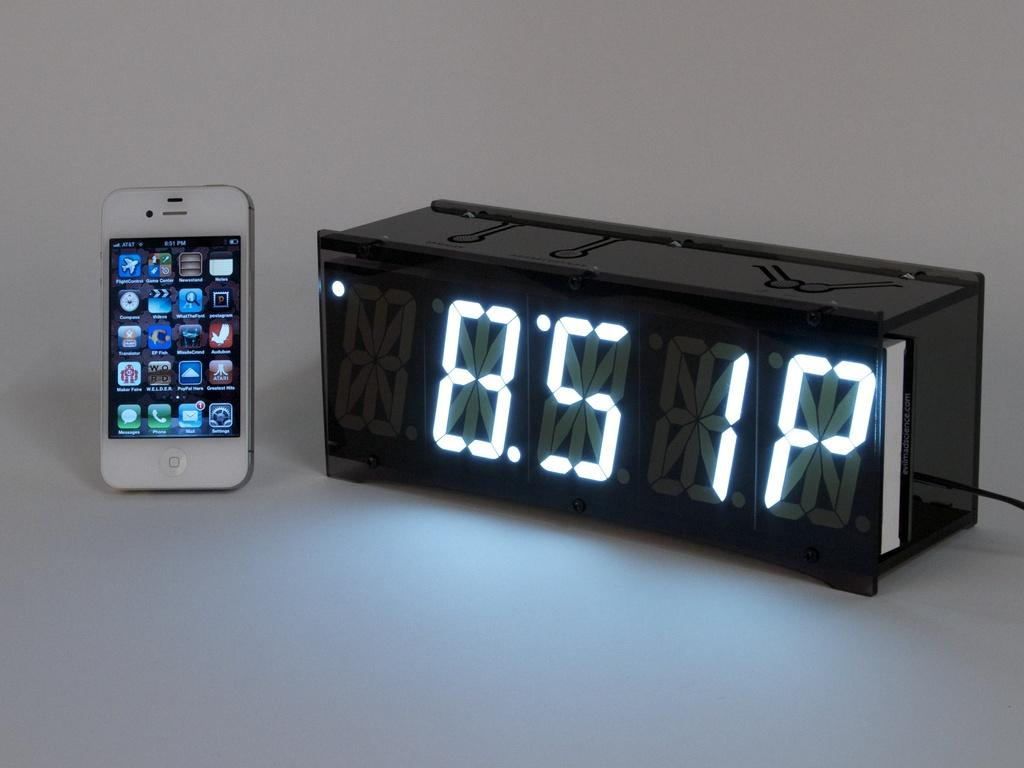<image>
Provide a brief description of the given image. A digital black clock displays the time of 8:51 P. 